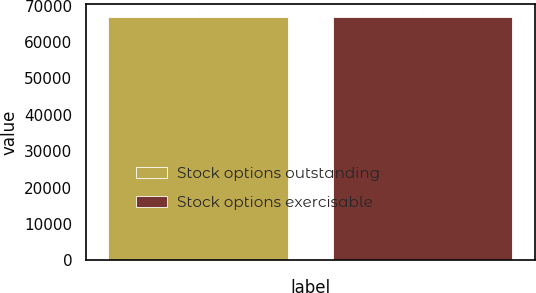Convert chart to OTSL. <chart><loc_0><loc_0><loc_500><loc_500><bar_chart><fcel>Stock options outstanding<fcel>Stock options exercisable<nl><fcel>67044<fcel>66964<nl></chart> 